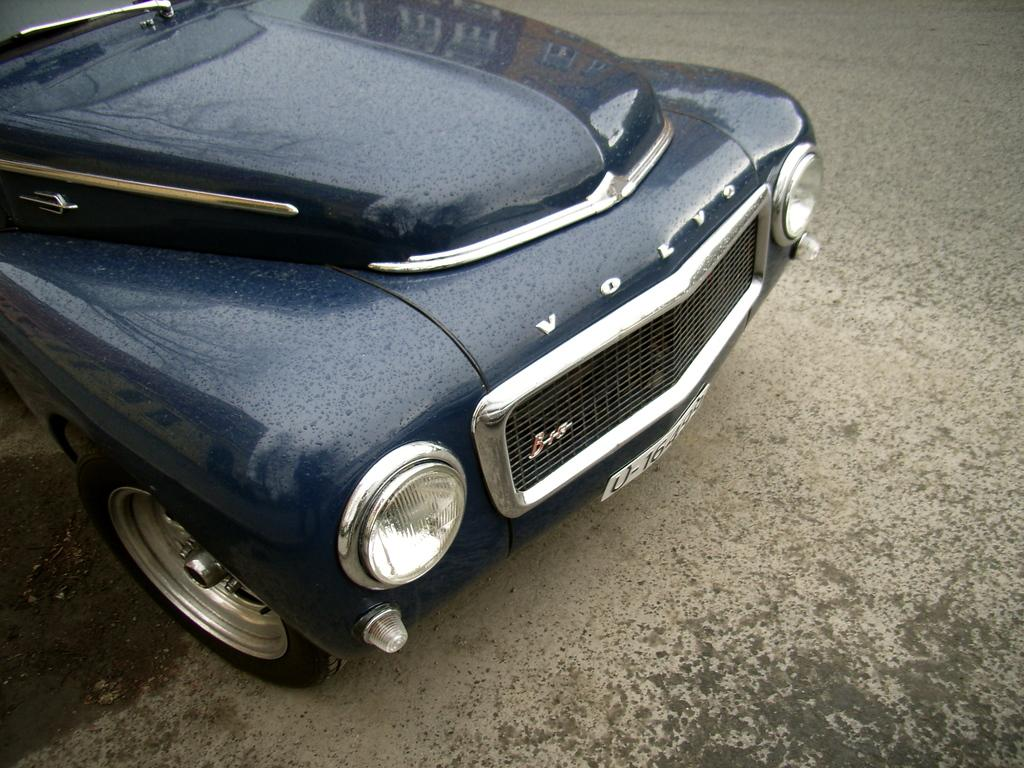What is the main subject of the picture? The main subject of the picture is a car. What color is the car in the picture? The car is blue in color. What is the name of the car in the picture? The car's name is Volvo. What time of day is it in the picture, and how does the car contribute to the morning light? The time of day is not mentioned in the image, and there is no indication of morning light. Additionally, the car does not contribute to the morning light, as it is a stationary object in the picture. 